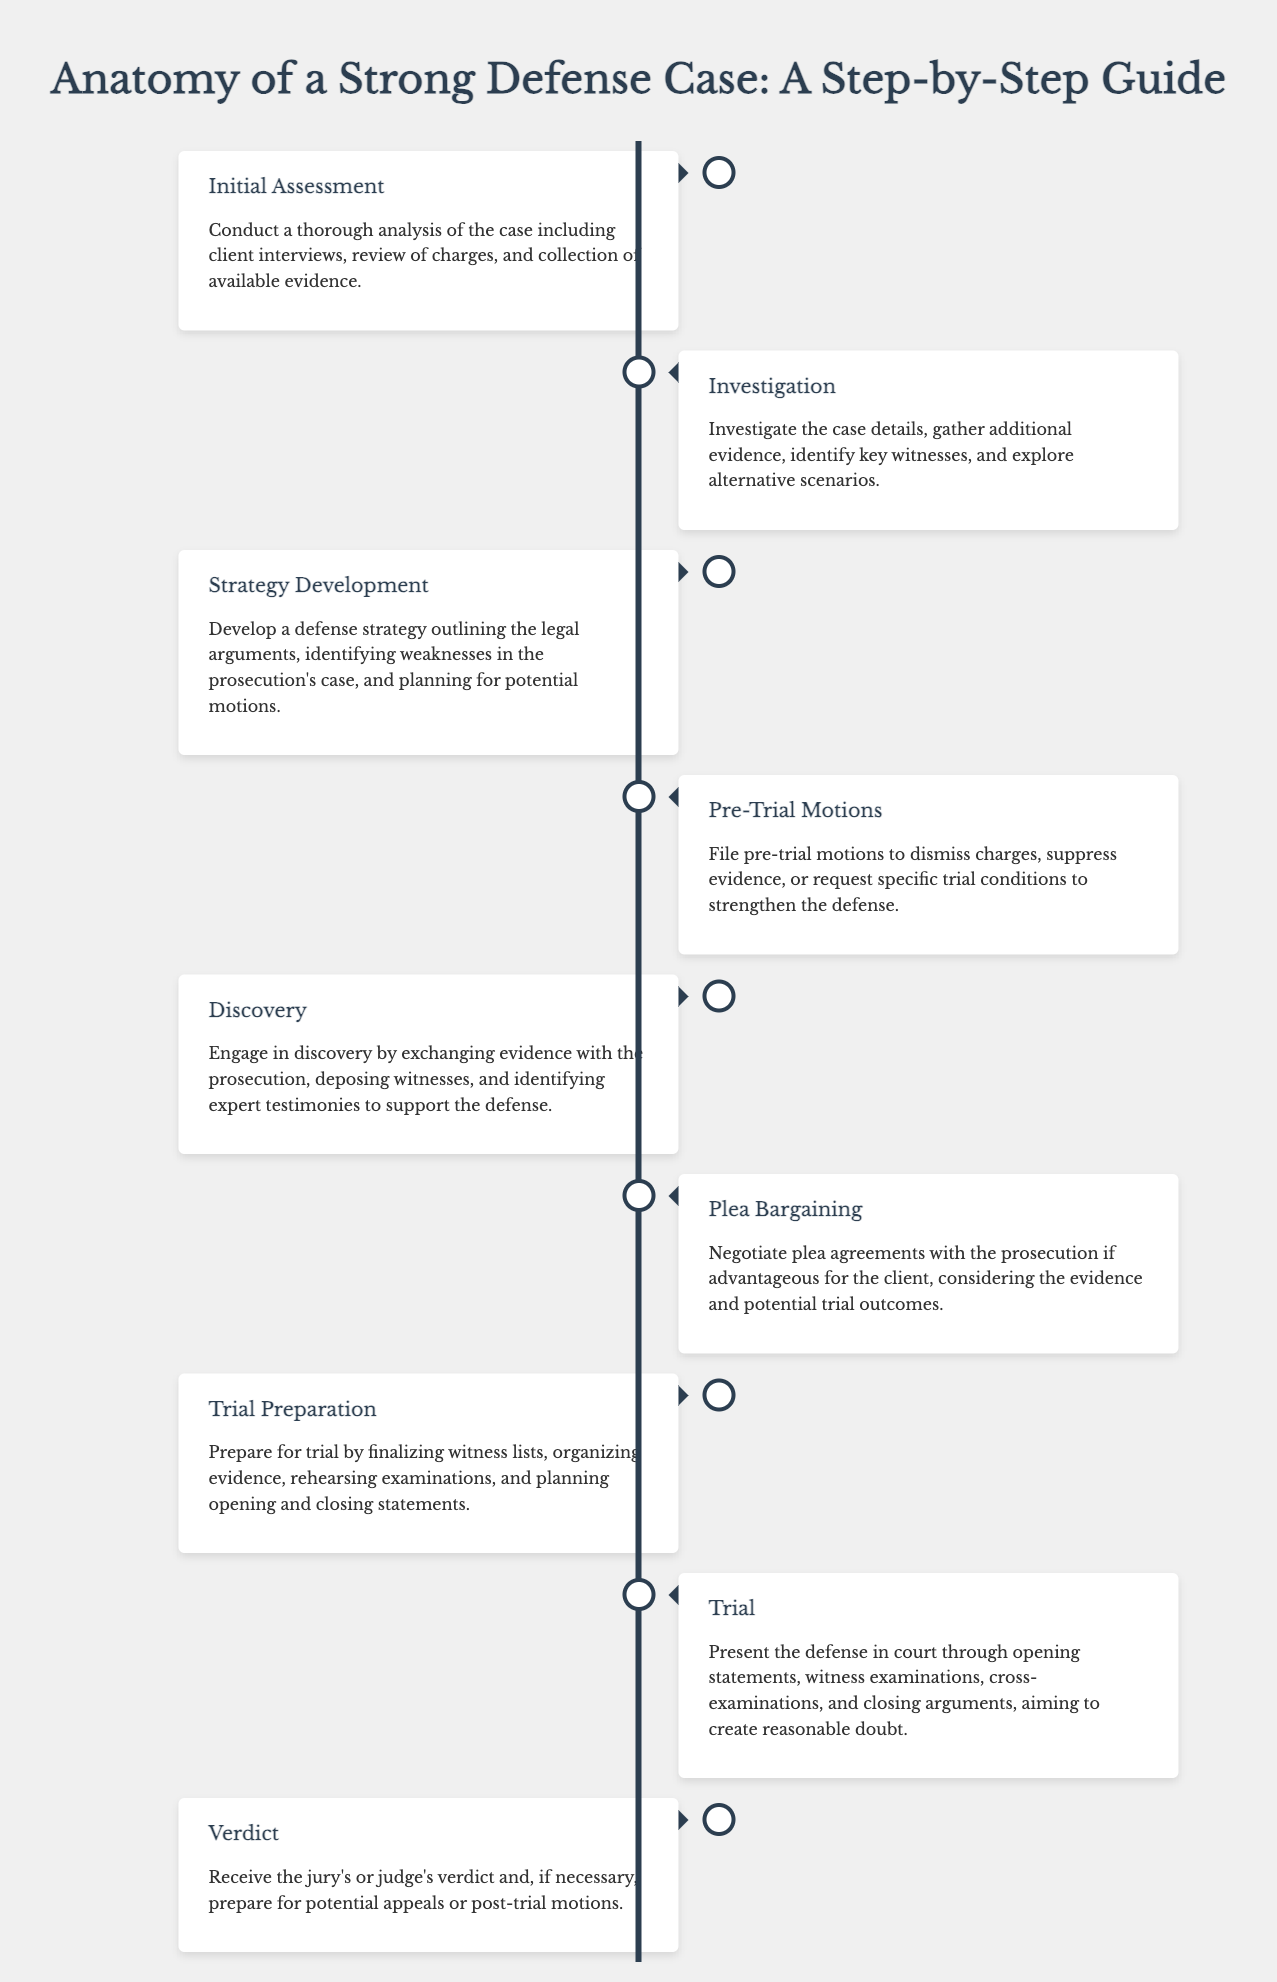What is the first phase of the defense case? The document lists "Initial Assessment" as the first phase of the defense case.
Answer: Initial Assessment How many total phases are there in a strong defense case? The document outlines a total of eight phases in the defense case process.
Answer: Eight What phase involves negotiating with the prosecution? The phase where negotiations with the prosecution take place is called "Plea Bargaining."
Answer: Plea Bargaining Which phase comes after "Discovery"? The phase that follows "Discovery" is "Plea Bargaining."
Answer: Plea Bargaining What icon represents the "Trial" phase? The document uses the gavel icon to represent the "Trial" phase.
Answer: Gavel icon What is the objective during the "Trial"? The primary objective during the "Trial" is to create reasonable doubt.
Answer: Create reasonable doubt What is produced at the conclusion of the defense case? At the conclusion of the defense case, a verdict is produced.
Answer: Verdict Which phase focuses on filing motions to suppress evidence? The phase that focuses on filing motions is "Pre-Trial Motions."
Answer: Pre-Trial Motions 